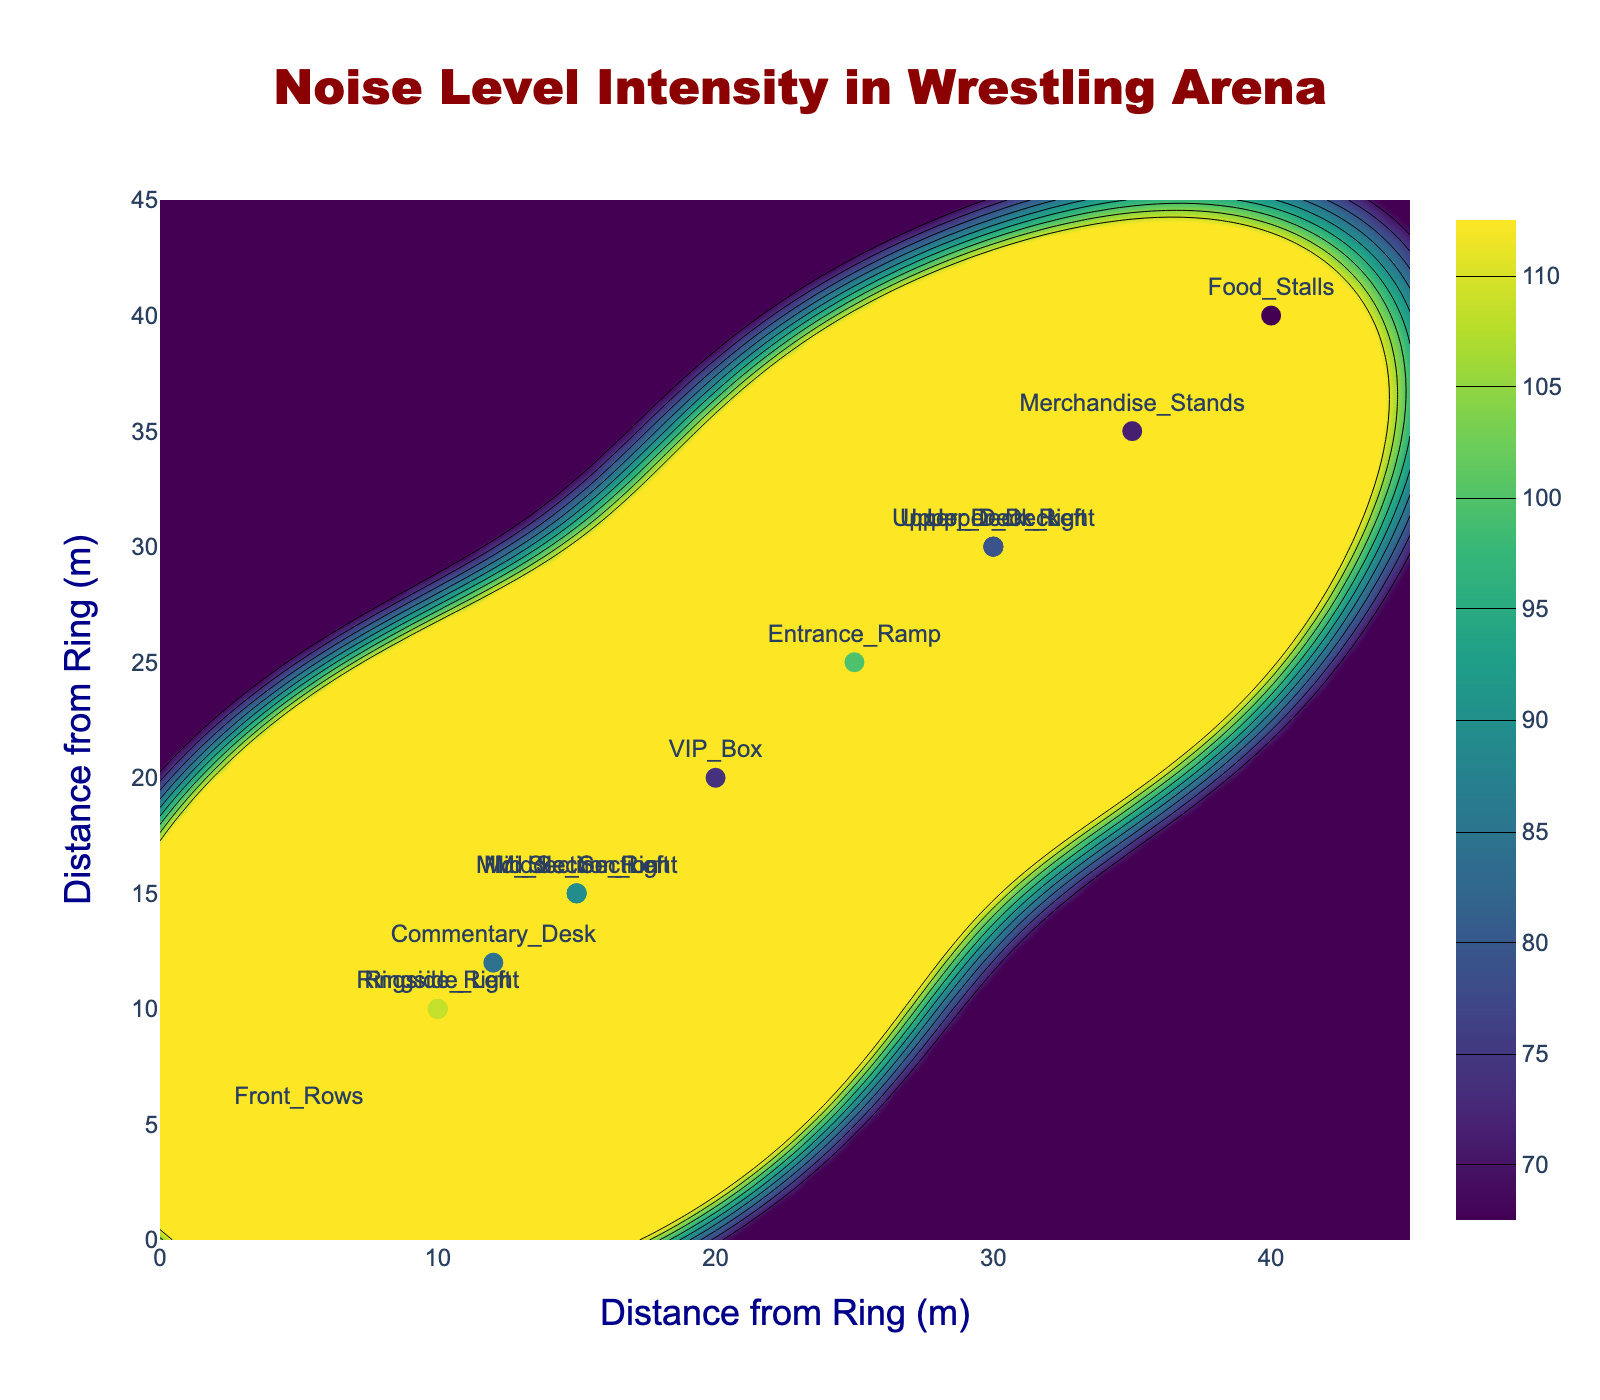How many distinct sections are labeled in the figure? The figure has markers with text labels on specific points. Count the unique section names displayed.
Answer: 14 Which section has the highest noise level and what is that level? Look for the section with the highest noise level indicated by the marker closest to the maximum value in the color scale and observe its labeled text.
Answer: Front Rows, 110 dB What is the range of noise levels in the arena? Identify the minimum and maximum noise levels from the color scale. Subtract the minimum from the maximum to get the range.
Answer: 75 dB to 110 dB (range: 35 dB) Which sections are closer to the ring, Ringside_Left or Commentary_Desk? Compare the distances from the ring for both sections. Ringside_Left is at 10 meters and Commentary_Desk is at 12 meters.
Answer: Ringside_Left How does the noise level at the VIP_Box compare to the Entrance_Ramp? Look at the noise levels labeled for VIP_Box (80 dB) and Entrance_Ramp (100 dB) and note the difference.
Answer: VIP_Box is 20 dB lower than Entrance_Ramp What is the average of the noise levels at the Front_Rows, Middle_Section, and Upper_Deck? Sum the noise levels of Front_Rows (110 dB), Middle_Section (95 dB), and Upper_Deck (85 dB) and divide by 3.
Answer: 96.67 dB How does the noise level in the Mid_Section compare between left and right side sections? Compare the noise levels labeled for Mid_Section_Left (90 dB) and Mid_Section_Right (92 dB).
Answer: Mid_Section_Right is 2 dB higher than Mid_Section_Left Which section is the quietest and what is its noise level? Look for the section with the lowest noise level indicated by the marker closest to the minimum value in the color scale and observe its labeled text.
Answer: Food_Stalls, 75 dB What is the predominant color around the Ringside regions on the contour plot and what noise range does it represent? Observe the color directly surrounding the Ringside_Left and Ringside_Right points and refer to the color scale to find its noise range.
Answer: Dark yellow-green, around 105-107 dB Are any sections more than 30 meters away from the ring and if so, what are their noise levels? Identify sections with distances greater than 30 meters and list their noise levels.
Answer: Upper_Deck, Upper_Deck_Left, Upper_Deck_Right, Merchandise_Stands, Food_Stalls; Noise levels: 85 dB, 83 dB, 84 dB, 78 dB, 75 dB 